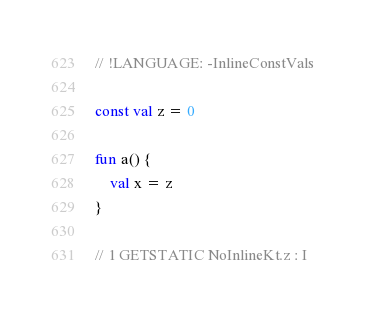<code> <loc_0><loc_0><loc_500><loc_500><_Kotlin_>// !LANGUAGE: -InlineConstVals

const val z = 0

fun a() {
    val x = z
}

// 1 GETSTATIC NoInlineKt.z : I
</code> 